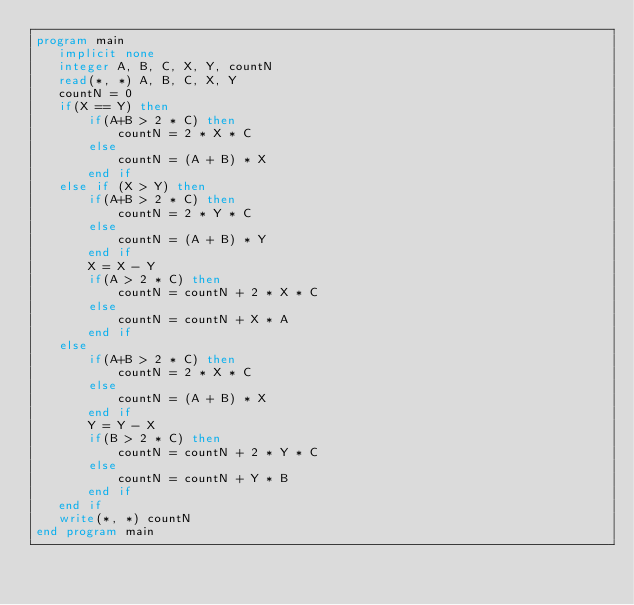Convert code to text. <code><loc_0><loc_0><loc_500><loc_500><_FORTRAN_>program main
   implicit none
   integer A, B, C, X, Y, countN
   read(*, *) A, B, C, X, Y
   countN = 0
   if(X == Y) then
       if(A+B > 2 * C) then
	       countN = 2 * X * C
	   else
	       countN = (A + B) * X
	   end if
   else if (X > Y) then
       if(A+B > 2 * C) then
	       countN = 2 * Y * C
	   else
	       countN = (A + B) * Y
	   end if
	   X = X - Y
	   if(A > 2 * C) then
	       countN = countN + 2 * X * C
	   else
	       countN = countN + X * A
	   end if
   else
       if(A+B > 2 * C) then
	       countN = 2 * X * C
	   else
	       countN = (A + B) * X
	   end if
	   Y = Y - X
	   if(B > 2 * C) then
	       countN = countN + 2 * Y * C
	   else
	       countN = countN + Y * B
	   end if
   end if
   write(*, *) countN   
end program main</code> 